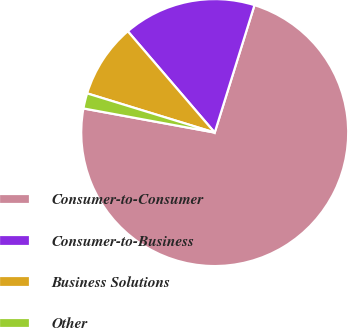<chart> <loc_0><loc_0><loc_500><loc_500><pie_chart><fcel>Consumer-to-Consumer<fcel>Consumer-to-Business<fcel>Business Solutions<fcel>Other<nl><fcel>73.08%<fcel>16.1%<fcel>8.97%<fcel>1.85%<nl></chart> 